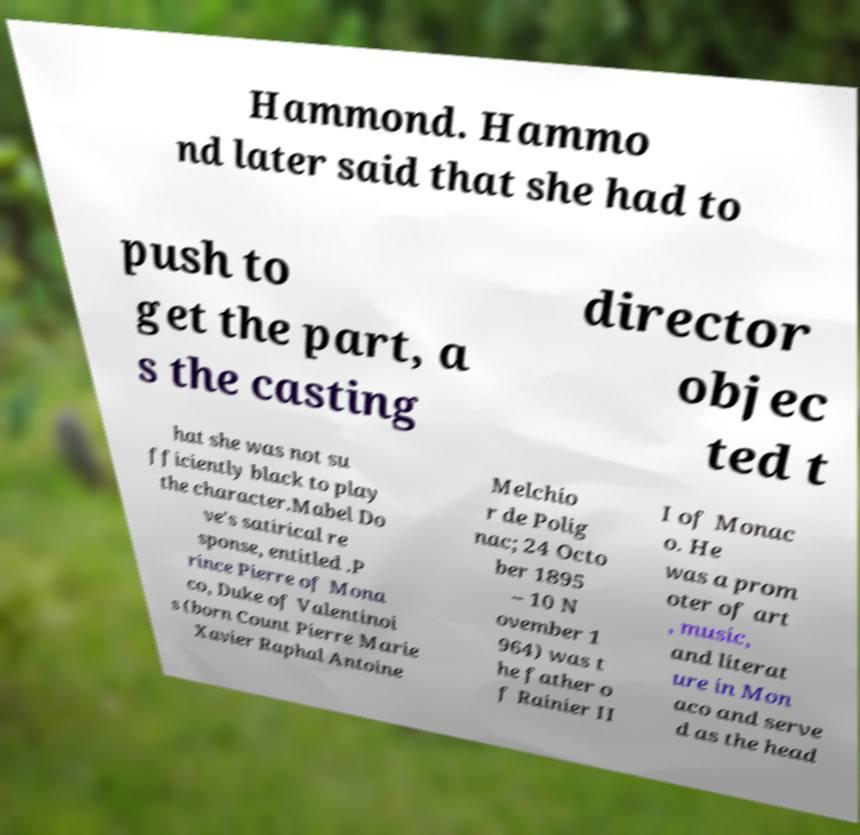Could you assist in decoding the text presented in this image and type it out clearly? Hammond. Hammo nd later said that she had to push to get the part, a s the casting director objec ted t hat she was not su fficiently black to play the character.Mabel Do ve's satirical re sponse, entitled .P rince Pierre of Mona co, Duke of Valentinoi s (born Count Pierre Marie Xavier Raphal Antoine Melchio r de Polig nac; 24 Octo ber 1895 – 10 N ovember 1 964) was t he father o f Rainier II I of Monac o. He was a prom oter of art , music, and literat ure in Mon aco and serve d as the head 